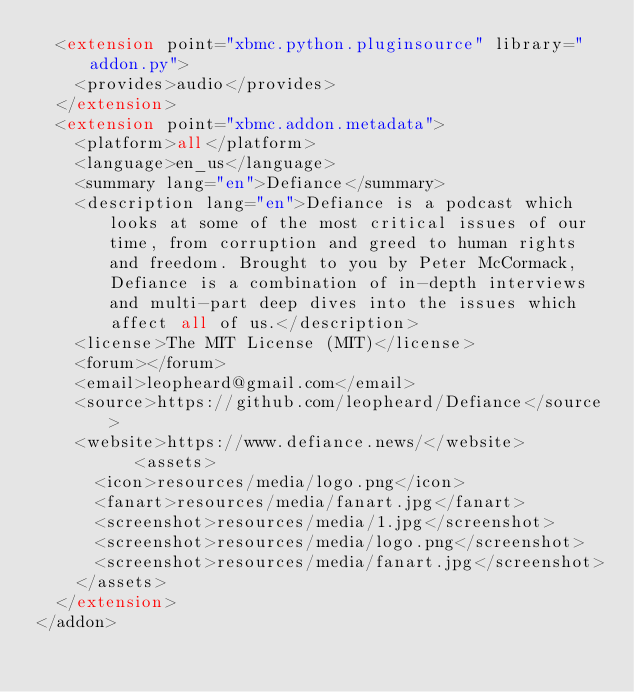Convert code to text. <code><loc_0><loc_0><loc_500><loc_500><_XML_>  <extension point="xbmc.python.pluginsource" library="addon.py">
    <provides>audio</provides>
  </extension>
  <extension point="xbmc.addon.metadata">
    <platform>all</platform>
    <language>en_us</language>
    <summary lang="en">Defiance</summary>
    <description lang="en">Defiance is a podcast which looks at some of the most critical issues of our time, from corruption and greed to human rights and freedom. Brought to you by Peter McCormack, Defiance is a combination of in-depth interviews and multi-part deep dives into the issues which affect all of us.</description>
    <license>The MIT License (MIT)</license>
    <forum></forum>
    <email>leopheard@gmail.com</email>
    <source>https://github.com/leopheard/Defiance</source>
    <website>https://www.defiance.news/</website>
        	<assets>
			<icon>resources/media/logo.png</icon>
			<fanart>resources/media/fanart.jpg</fanart>
			<screenshot>resources/media/1.jpg</screenshot>
			<screenshot>resources/media/logo.png</screenshot>
			<screenshot>resources/media/fanart.jpg</screenshot>
		</assets>
  </extension>
</addon>
</code> 